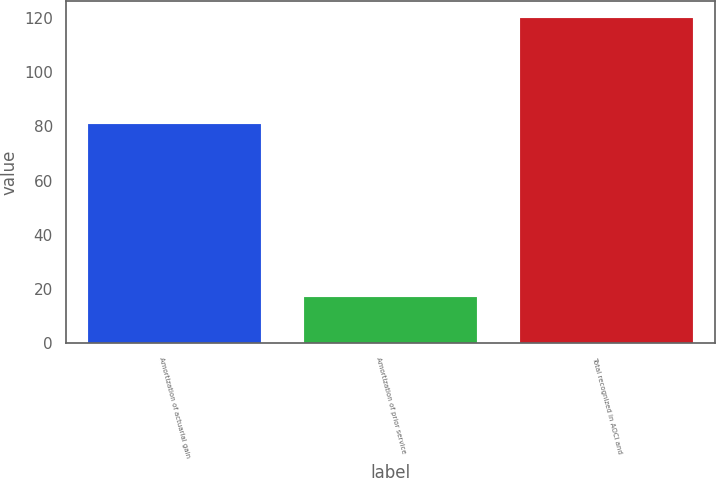Convert chart. <chart><loc_0><loc_0><loc_500><loc_500><bar_chart><fcel>Amortization of actuarial gain<fcel>Amortization of prior service<fcel>Total recognized in AOCI and<nl><fcel>81<fcel>17<fcel>120<nl></chart> 